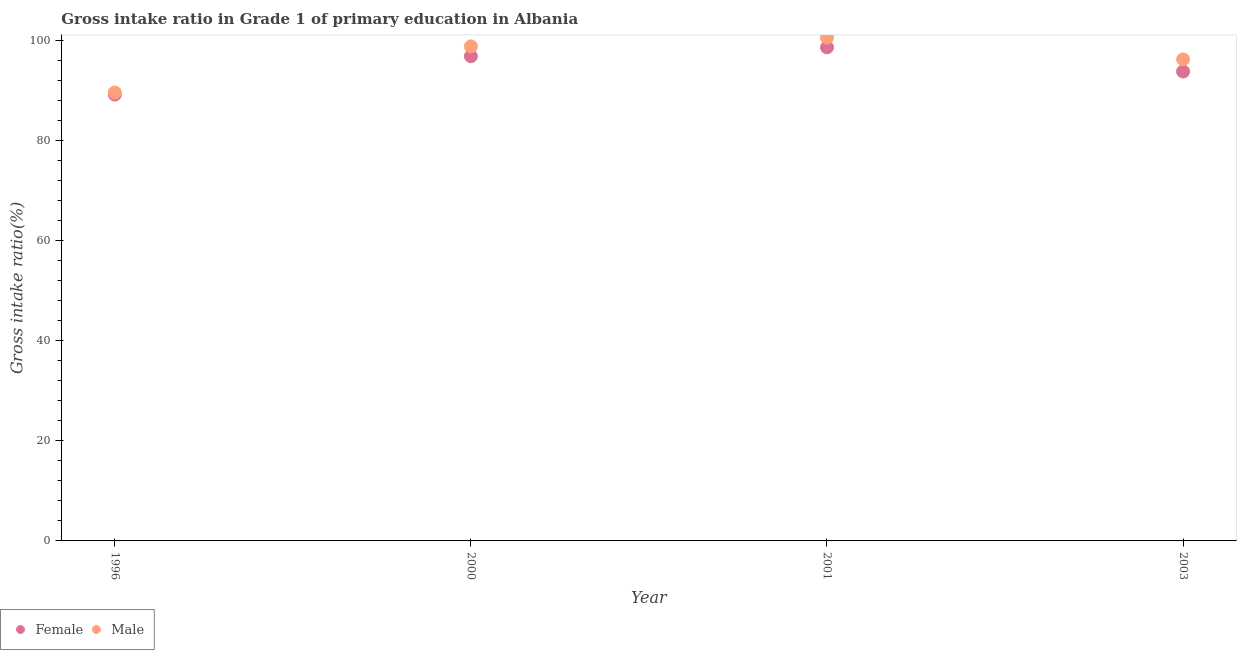How many different coloured dotlines are there?
Offer a terse response. 2. Is the number of dotlines equal to the number of legend labels?
Your response must be concise. Yes. What is the gross intake ratio(male) in 2003?
Keep it short and to the point. 96.26. Across all years, what is the maximum gross intake ratio(male)?
Offer a very short reply. 100.59. Across all years, what is the minimum gross intake ratio(female)?
Offer a terse response. 89.23. In which year was the gross intake ratio(female) minimum?
Give a very brief answer. 1996. What is the total gross intake ratio(female) in the graph?
Give a very brief answer. 378.62. What is the difference between the gross intake ratio(female) in 2000 and that in 2003?
Keep it short and to the point. 3.06. What is the difference between the gross intake ratio(female) in 2003 and the gross intake ratio(male) in 1996?
Your answer should be compact. 4.2. What is the average gross intake ratio(female) per year?
Your answer should be very brief. 94.65. In the year 2003, what is the difference between the gross intake ratio(male) and gross intake ratio(female)?
Offer a very short reply. 2.42. What is the ratio of the gross intake ratio(female) in 1996 to that in 2003?
Your answer should be very brief. 0.95. Is the difference between the gross intake ratio(female) in 1996 and 2003 greater than the difference between the gross intake ratio(male) in 1996 and 2003?
Offer a terse response. Yes. What is the difference between the highest and the second highest gross intake ratio(male)?
Ensure brevity in your answer.  1.73. What is the difference between the highest and the lowest gross intake ratio(male)?
Your response must be concise. 10.96. In how many years, is the gross intake ratio(male) greater than the average gross intake ratio(male) taken over all years?
Give a very brief answer. 2. Is the sum of the gross intake ratio(male) in 2000 and 2003 greater than the maximum gross intake ratio(female) across all years?
Your answer should be very brief. Yes. Is the gross intake ratio(male) strictly greater than the gross intake ratio(female) over the years?
Offer a terse response. Yes. How many dotlines are there?
Your answer should be very brief. 2. Does the graph contain any zero values?
Your answer should be compact. No. Does the graph contain grids?
Give a very brief answer. No. How many legend labels are there?
Your answer should be very brief. 2. How are the legend labels stacked?
Give a very brief answer. Horizontal. What is the title of the graph?
Offer a very short reply. Gross intake ratio in Grade 1 of primary education in Albania. What is the label or title of the Y-axis?
Your response must be concise. Gross intake ratio(%). What is the Gross intake ratio(%) in Female in 1996?
Make the answer very short. 89.23. What is the Gross intake ratio(%) in Male in 1996?
Make the answer very short. 89.64. What is the Gross intake ratio(%) of Female in 2000?
Give a very brief answer. 96.89. What is the Gross intake ratio(%) of Male in 2000?
Your answer should be very brief. 98.86. What is the Gross intake ratio(%) of Female in 2001?
Provide a succinct answer. 98.66. What is the Gross intake ratio(%) in Male in 2001?
Your answer should be very brief. 100.59. What is the Gross intake ratio(%) of Female in 2003?
Your answer should be compact. 93.83. What is the Gross intake ratio(%) of Male in 2003?
Your answer should be compact. 96.26. Across all years, what is the maximum Gross intake ratio(%) of Female?
Offer a terse response. 98.66. Across all years, what is the maximum Gross intake ratio(%) of Male?
Keep it short and to the point. 100.59. Across all years, what is the minimum Gross intake ratio(%) in Female?
Give a very brief answer. 89.23. Across all years, what is the minimum Gross intake ratio(%) in Male?
Ensure brevity in your answer.  89.64. What is the total Gross intake ratio(%) in Female in the graph?
Ensure brevity in your answer.  378.62. What is the total Gross intake ratio(%) of Male in the graph?
Keep it short and to the point. 385.35. What is the difference between the Gross intake ratio(%) in Female in 1996 and that in 2000?
Provide a succinct answer. -7.66. What is the difference between the Gross intake ratio(%) in Male in 1996 and that in 2000?
Provide a short and direct response. -9.23. What is the difference between the Gross intake ratio(%) in Female in 1996 and that in 2001?
Give a very brief answer. -9.43. What is the difference between the Gross intake ratio(%) of Male in 1996 and that in 2001?
Provide a succinct answer. -10.96. What is the difference between the Gross intake ratio(%) of Female in 1996 and that in 2003?
Give a very brief answer. -4.6. What is the difference between the Gross intake ratio(%) of Male in 1996 and that in 2003?
Make the answer very short. -6.62. What is the difference between the Gross intake ratio(%) in Female in 2000 and that in 2001?
Make the answer very short. -1.77. What is the difference between the Gross intake ratio(%) in Male in 2000 and that in 2001?
Make the answer very short. -1.73. What is the difference between the Gross intake ratio(%) in Female in 2000 and that in 2003?
Provide a succinct answer. 3.06. What is the difference between the Gross intake ratio(%) of Male in 2000 and that in 2003?
Give a very brief answer. 2.61. What is the difference between the Gross intake ratio(%) in Female in 2001 and that in 2003?
Your answer should be compact. 4.83. What is the difference between the Gross intake ratio(%) of Male in 2001 and that in 2003?
Provide a short and direct response. 4.33. What is the difference between the Gross intake ratio(%) in Female in 1996 and the Gross intake ratio(%) in Male in 2000?
Make the answer very short. -9.63. What is the difference between the Gross intake ratio(%) in Female in 1996 and the Gross intake ratio(%) in Male in 2001?
Make the answer very short. -11.36. What is the difference between the Gross intake ratio(%) of Female in 1996 and the Gross intake ratio(%) of Male in 2003?
Keep it short and to the point. -7.03. What is the difference between the Gross intake ratio(%) of Female in 2000 and the Gross intake ratio(%) of Male in 2001?
Provide a succinct answer. -3.7. What is the difference between the Gross intake ratio(%) of Female in 2000 and the Gross intake ratio(%) of Male in 2003?
Keep it short and to the point. 0.63. What is the difference between the Gross intake ratio(%) of Female in 2001 and the Gross intake ratio(%) of Male in 2003?
Offer a very short reply. 2.41. What is the average Gross intake ratio(%) of Female per year?
Ensure brevity in your answer.  94.65. What is the average Gross intake ratio(%) of Male per year?
Give a very brief answer. 96.34. In the year 1996, what is the difference between the Gross intake ratio(%) of Female and Gross intake ratio(%) of Male?
Ensure brevity in your answer.  -0.41. In the year 2000, what is the difference between the Gross intake ratio(%) in Female and Gross intake ratio(%) in Male?
Your response must be concise. -1.97. In the year 2001, what is the difference between the Gross intake ratio(%) of Female and Gross intake ratio(%) of Male?
Provide a succinct answer. -1.93. In the year 2003, what is the difference between the Gross intake ratio(%) of Female and Gross intake ratio(%) of Male?
Keep it short and to the point. -2.42. What is the ratio of the Gross intake ratio(%) of Female in 1996 to that in 2000?
Keep it short and to the point. 0.92. What is the ratio of the Gross intake ratio(%) of Male in 1996 to that in 2000?
Your answer should be compact. 0.91. What is the ratio of the Gross intake ratio(%) of Female in 1996 to that in 2001?
Your answer should be very brief. 0.9. What is the ratio of the Gross intake ratio(%) of Male in 1996 to that in 2001?
Your answer should be compact. 0.89. What is the ratio of the Gross intake ratio(%) in Female in 1996 to that in 2003?
Offer a terse response. 0.95. What is the ratio of the Gross intake ratio(%) of Male in 1996 to that in 2003?
Keep it short and to the point. 0.93. What is the ratio of the Gross intake ratio(%) of Female in 2000 to that in 2001?
Provide a succinct answer. 0.98. What is the ratio of the Gross intake ratio(%) of Male in 2000 to that in 2001?
Keep it short and to the point. 0.98. What is the ratio of the Gross intake ratio(%) of Female in 2000 to that in 2003?
Make the answer very short. 1.03. What is the ratio of the Gross intake ratio(%) in Male in 2000 to that in 2003?
Offer a very short reply. 1.03. What is the ratio of the Gross intake ratio(%) of Female in 2001 to that in 2003?
Make the answer very short. 1.05. What is the ratio of the Gross intake ratio(%) of Male in 2001 to that in 2003?
Offer a very short reply. 1.04. What is the difference between the highest and the second highest Gross intake ratio(%) in Female?
Make the answer very short. 1.77. What is the difference between the highest and the second highest Gross intake ratio(%) of Male?
Provide a short and direct response. 1.73. What is the difference between the highest and the lowest Gross intake ratio(%) in Female?
Offer a terse response. 9.43. What is the difference between the highest and the lowest Gross intake ratio(%) of Male?
Give a very brief answer. 10.96. 